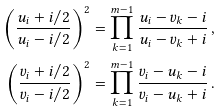<formula> <loc_0><loc_0><loc_500><loc_500>\left ( \frac { u _ { i } + i / 2 } { u _ { i } - i / 2 } \right ) ^ { 2 } = \prod _ { k = 1 } ^ { m - 1 } \frac { u _ { i } - v _ { k } - i } { u _ { i } - v _ { k } + i } \, , \\ \left ( \frac { v _ { i } + i / 2 } { v _ { i } - i / 2 } \right ) ^ { 2 } = \prod _ { k = 1 } ^ { m - 1 } \frac { v _ { i } - u _ { k } - i } { v _ { i } - u _ { k } + i } \, .</formula> 